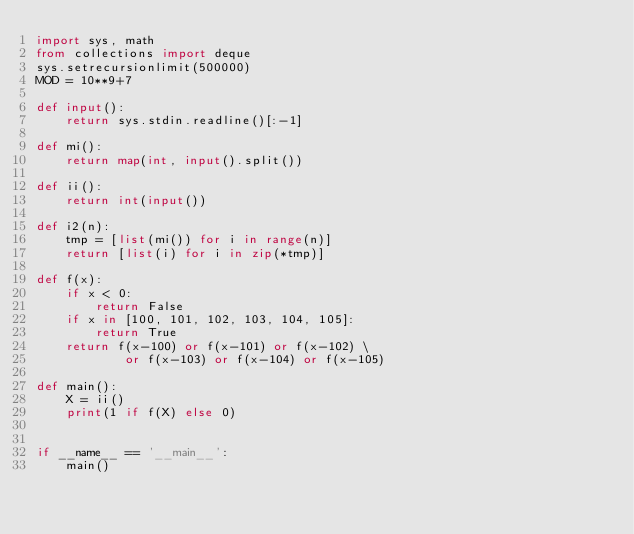Convert code to text. <code><loc_0><loc_0><loc_500><loc_500><_Python_>import sys, math
from collections import deque
sys.setrecursionlimit(500000)
MOD = 10**9+7

def input():
    return sys.stdin.readline()[:-1]

def mi():
    return map(int, input().split())

def ii():
    return int(input())

def i2(n):
    tmp = [list(mi()) for i in range(n)]
    return [list(i) for i in zip(*tmp)]

def f(x):
    if x < 0:
        return False
    if x in [100, 101, 102, 103, 104, 105]:
        return True
    return f(x-100) or f(x-101) or f(x-102) \
            or f(x-103) or f(x-104) or f(x-105)

def main():
    X = ii()
    print(1 if f(X) else 0)


if __name__ == '__main__':
    main()</code> 